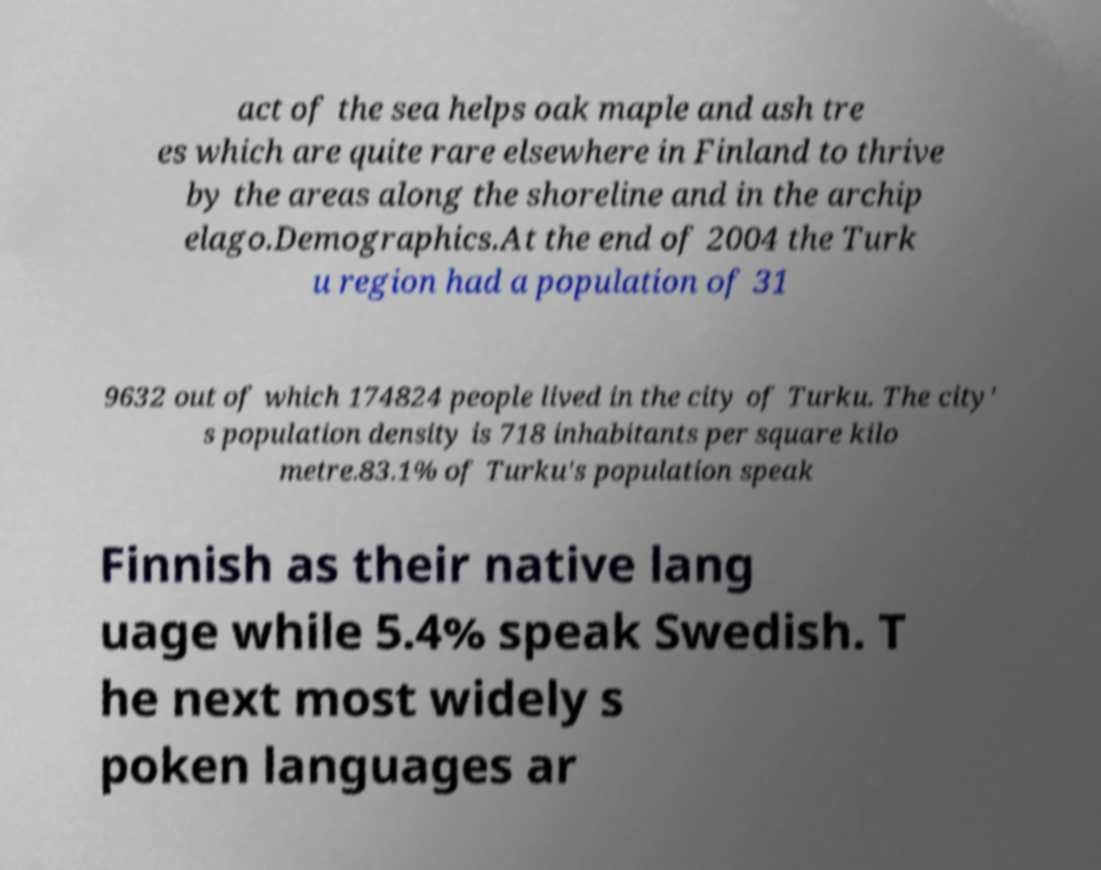Can you read and provide the text displayed in the image?This photo seems to have some interesting text. Can you extract and type it out for me? act of the sea helps oak maple and ash tre es which are quite rare elsewhere in Finland to thrive by the areas along the shoreline and in the archip elago.Demographics.At the end of 2004 the Turk u region had a population of 31 9632 out of which 174824 people lived in the city of Turku. The city' s population density is 718 inhabitants per square kilo metre.83.1% of Turku's population speak Finnish as their native lang uage while 5.4% speak Swedish. T he next most widely s poken languages ar 